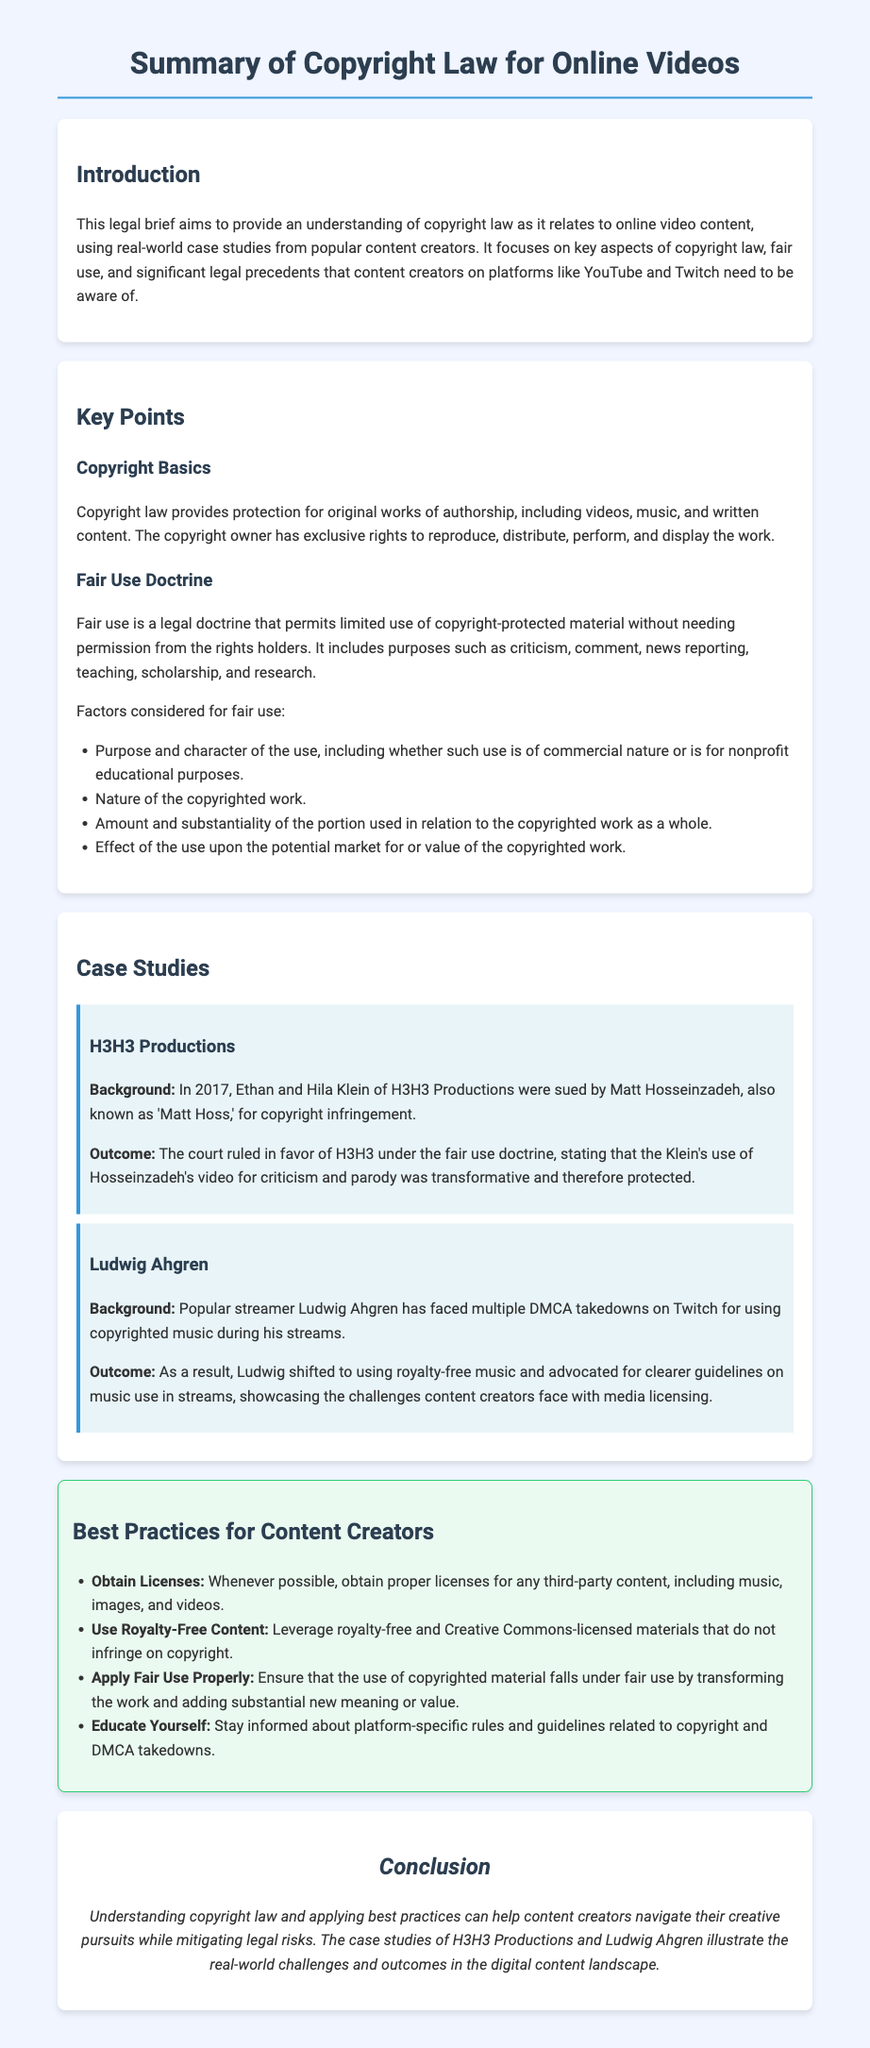What is the title of the legal brief? The title of the legal brief is provided in the document's heading.
Answer: Summary of Copyright Law for Online Videos What year was H3H3 Productions sued? The document states that H3H3 Productions was sued in 2017.
Answer: 2017 Who are the founders of H3H3 Productions? The document mentions that Ethan and Hila Klein are the founders of H3H3 Productions.
Answer: Ethan and Hila Klein What is a primary factor considered for fair use? The document lists multiple factors; one of them is mentioned first in the text.
Answer: Purpose and character of the use What was Ludwig Ahgren's challenge related to? The document notes that Ludwig faced challenges with music during his streams.
Answer: Copyrighted music What legal doctrine allows limited use of copyrighted material? The document explicitly identifies a key legal concept related to copyright use.
Answer: Fair Use Doctrine Which case study emphasized the importance of royalty-free music? The document indicates which content creator had to adjust their practices due to legal issues.
Answer: Ludwig Ahgren What do content creators need to stay informed about, according to the best practices? The best practices section suggests a specific area of knowledge for creators.
Answer: Platform-specific rules and guidelines 